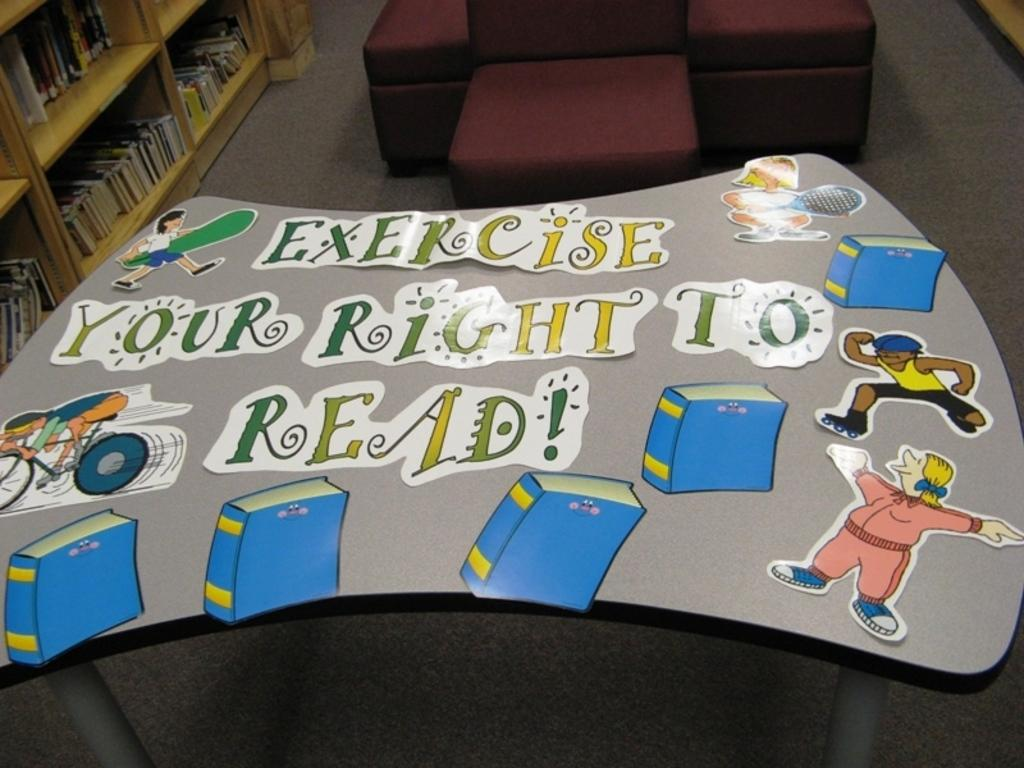<image>
Write a terse but informative summary of the picture. A sign telling people they should exercise their right to read. 